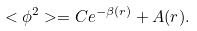<formula> <loc_0><loc_0><loc_500><loc_500>< \phi ^ { 2 } > = C e ^ { - \beta ( r ) } + A ( r ) .</formula> 